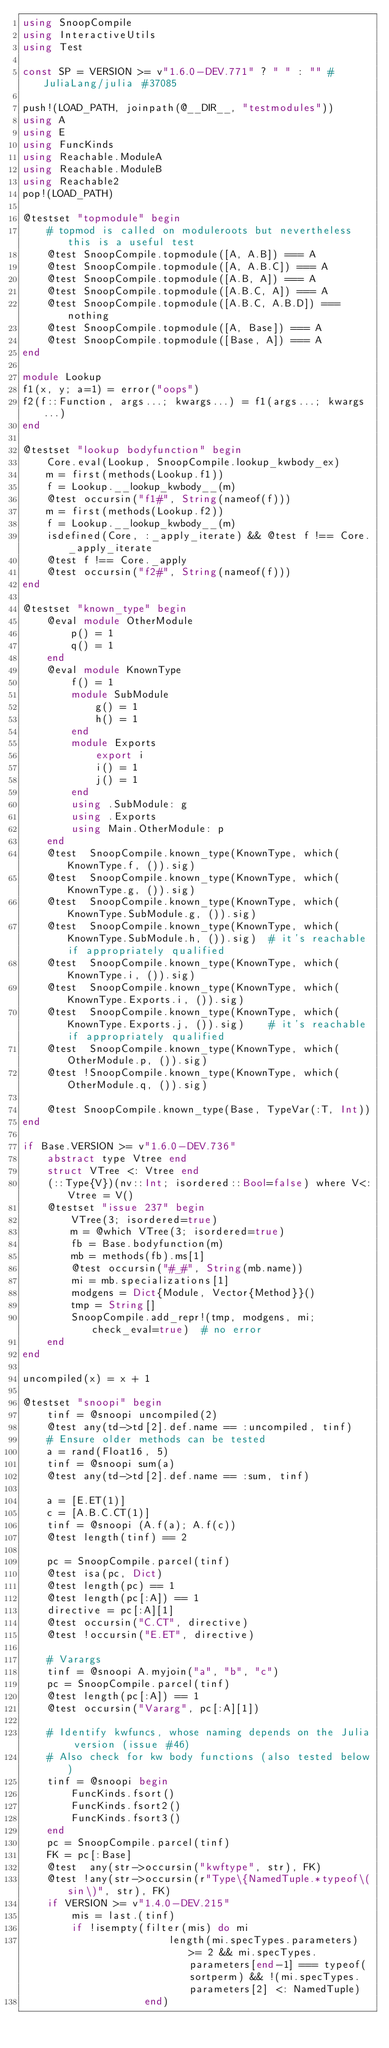<code> <loc_0><loc_0><loc_500><loc_500><_Julia_>using SnoopCompile
using InteractiveUtils
using Test

const SP = VERSION >= v"1.6.0-DEV.771" ? " " : "" # JuliaLang/julia #37085

push!(LOAD_PATH, joinpath(@__DIR__, "testmodules"))
using A
using E
using FuncKinds
using Reachable.ModuleA
using Reachable.ModuleB
using Reachable2
pop!(LOAD_PATH)

@testset "topmodule" begin
    # topmod is called on moduleroots but nevertheless this is a useful test
    @test SnoopCompile.topmodule([A, A.B]) === A
    @test SnoopCompile.topmodule([A, A.B.C]) === A
    @test SnoopCompile.topmodule([A.B, A]) === A
    @test SnoopCompile.topmodule([A.B.C, A]) === A
    @test SnoopCompile.topmodule([A.B.C, A.B.D]) === nothing
    @test SnoopCompile.topmodule([A, Base]) === A
    @test SnoopCompile.topmodule([Base, A]) === A
end

module Lookup
f1(x, y; a=1) = error("oops")
f2(f::Function, args...; kwargs...) = f1(args...; kwargs...)
end

@testset "lookup bodyfunction" begin
    Core.eval(Lookup, SnoopCompile.lookup_kwbody_ex)
    m = first(methods(Lookup.f1))
    f = Lookup.__lookup_kwbody__(m)
    @test occursin("f1#", String(nameof(f)))
    m = first(methods(Lookup.f2))
    f = Lookup.__lookup_kwbody__(m)
    isdefined(Core, :_apply_iterate) && @test f !== Core._apply_iterate
    @test f !== Core._apply
    @test occursin("f2#", String(nameof(f)))
end

@testset "known_type" begin
    @eval module OtherModule
        p() = 1
        q() = 1
    end
    @eval module KnownType
        f() = 1
        module SubModule
            g() = 1
            h() = 1
        end
        module Exports
            export i
            i() = 1
            j() = 1
        end
        using .SubModule: g
        using .Exports
        using Main.OtherModule: p
    end
    @test  SnoopCompile.known_type(KnownType, which(KnownType.f, ()).sig)
    @test  SnoopCompile.known_type(KnownType, which(KnownType.g, ()).sig)
    @test  SnoopCompile.known_type(KnownType, which(KnownType.SubModule.g, ()).sig)
    @test  SnoopCompile.known_type(KnownType, which(KnownType.SubModule.h, ()).sig)  # it's reachable if appropriately qualified
    @test  SnoopCompile.known_type(KnownType, which(KnownType.i, ()).sig)
    @test  SnoopCompile.known_type(KnownType, which(KnownType.Exports.i, ()).sig)
    @test  SnoopCompile.known_type(KnownType, which(KnownType.Exports.j, ()).sig)    # it's reachable if appropriately qualified
    @test  SnoopCompile.known_type(KnownType, which(OtherModule.p, ()).sig)
    @test !SnoopCompile.known_type(KnownType, which(OtherModule.q, ()).sig)

    @test SnoopCompile.known_type(Base, TypeVar(:T, Int))
end

if Base.VERSION >= v"1.6.0-DEV.736"
    abstract type Vtree end
    struct VTree <: Vtree end
    (::Type{V})(nv::Int; isordered::Bool=false) where V<:Vtree = V()
    @testset "issue 237" begin
        VTree(3; isordered=true)
        m = @which VTree(3; isordered=true)
        fb = Base.bodyfunction(m)
        mb = methods(fb).ms[1]
        @test occursin("#_#", String(mb.name))
        mi = mb.specializations[1]
        modgens = Dict{Module, Vector{Method}}()
        tmp = String[]
        SnoopCompile.add_repr!(tmp, modgens, mi; check_eval=true)  # no error
    end
end

uncompiled(x) = x + 1

@testset "snoopi" begin
    tinf = @snoopi uncompiled(2)
    @test any(td->td[2].def.name == :uncompiled, tinf)
    # Ensure older methods can be tested
    a = rand(Float16, 5)
    tinf = @snoopi sum(a)
    @test any(td->td[2].def.name == :sum, tinf)

    a = [E.ET(1)]
    c = [A.B.C.CT(1)]
    tinf = @snoopi (A.f(a); A.f(c))
    @test length(tinf) == 2

    pc = SnoopCompile.parcel(tinf)
    @test isa(pc, Dict)
    @test length(pc) == 1
    @test length(pc[:A]) == 1
    directive = pc[:A][1]
    @test occursin("C.CT", directive)
    @test !occursin("E.ET", directive)

    # Varargs
    tinf = @snoopi A.myjoin("a", "b", "c")
    pc = SnoopCompile.parcel(tinf)
    @test length(pc[:A]) == 1
    @test occursin("Vararg", pc[:A][1])

    # Identify kwfuncs, whose naming depends on the Julia version (issue #46)
    # Also check for kw body functions (also tested below)
    tinf = @snoopi begin
        FuncKinds.fsort()
        FuncKinds.fsort2()
        FuncKinds.fsort3()
    end
    pc = SnoopCompile.parcel(tinf)
    FK = pc[:Base]
    @test  any(str->occursin("kwftype", str), FK)
    @test !any(str->occursin(r"Type\{NamedTuple.*typeof\(sin\)", str), FK)
    if VERSION >= v"1.4.0-DEV.215"
        mis = last.(tinf)
        if !isempty(filter(mis) do mi
                        length(mi.specTypes.parameters) >= 2 && mi.specTypes.parameters[end-1] === typeof(sortperm) && !(mi.specTypes.parameters[2] <: NamedTuple)
                    end)</code> 